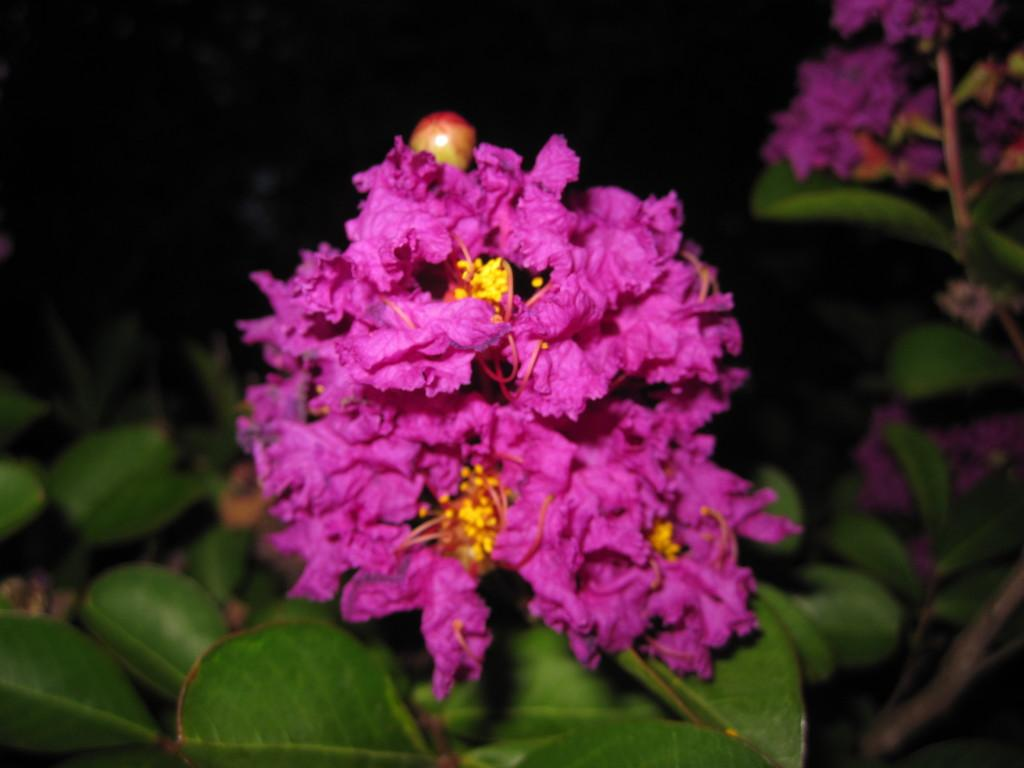What type of plants can be seen in the image? There are plants with flowers in the image. What can be observed about the background of the image? The background of the image is dark. What type of tools does the carpenter use in the image? There is no carpenter present in the image, so it is not possible to determine what tools they might use. 